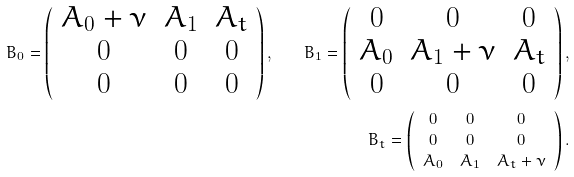<formula> <loc_0><loc_0><loc_500><loc_500>B _ { 0 } = \left ( \begin{array} { c c c } A _ { 0 } + \nu & A _ { 1 } & A _ { t } \\ 0 & 0 & 0 \\ 0 & 0 & 0 \end{array} \right ) , \quad B _ { 1 } = \left ( \begin{array} { c c c } 0 & 0 & 0 \\ A _ { 0 } & A _ { 1 } + \nu & A _ { t } \\ 0 & 0 & 0 \end{array} \right ) , \\ B _ { t } = \left ( \begin{array} { c c c } 0 & 0 & 0 \\ 0 & 0 & 0 \\ A _ { 0 } & A _ { 1 } & A _ { t } + \nu \end{array} \right ) .</formula> 